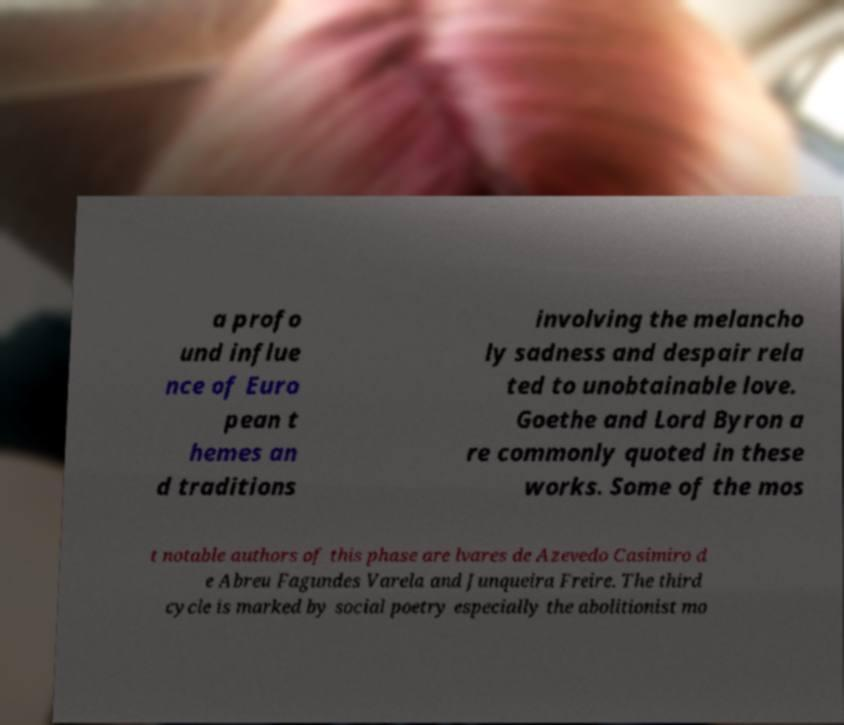Please read and relay the text visible in this image. What does it say? a profo und influe nce of Euro pean t hemes an d traditions involving the melancho ly sadness and despair rela ted to unobtainable love. Goethe and Lord Byron a re commonly quoted in these works. Some of the mos t notable authors of this phase are lvares de Azevedo Casimiro d e Abreu Fagundes Varela and Junqueira Freire. The third cycle is marked by social poetry especially the abolitionist mo 